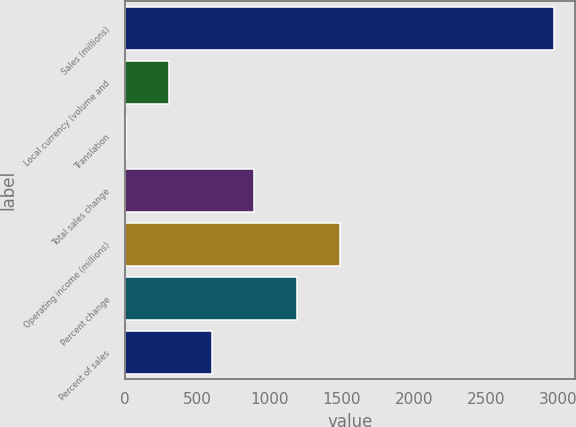<chart> <loc_0><loc_0><loc_500><loc_500><bar_chart><fcel>Sales (millions)<fcel>Local currency (volume and<fcel>Translation<fcel>Total sales change<fcel>Operating income (millions)<fcel>Percent change<fcel>Percent of sales<nl><fcel>2970<fcel>302.4<fcel>6<fcel>895.2<fcel>1488<fcel>1191.6<fcel>598.8<nl></chart> 